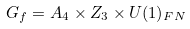Convert formula to latex. <formula><loc_0><loc_0><loc_500><loc_500>G _ { f } = A _ { 4 } \times Z _ { 3 } \times U ( 1 ) _ { F N }</formula> 